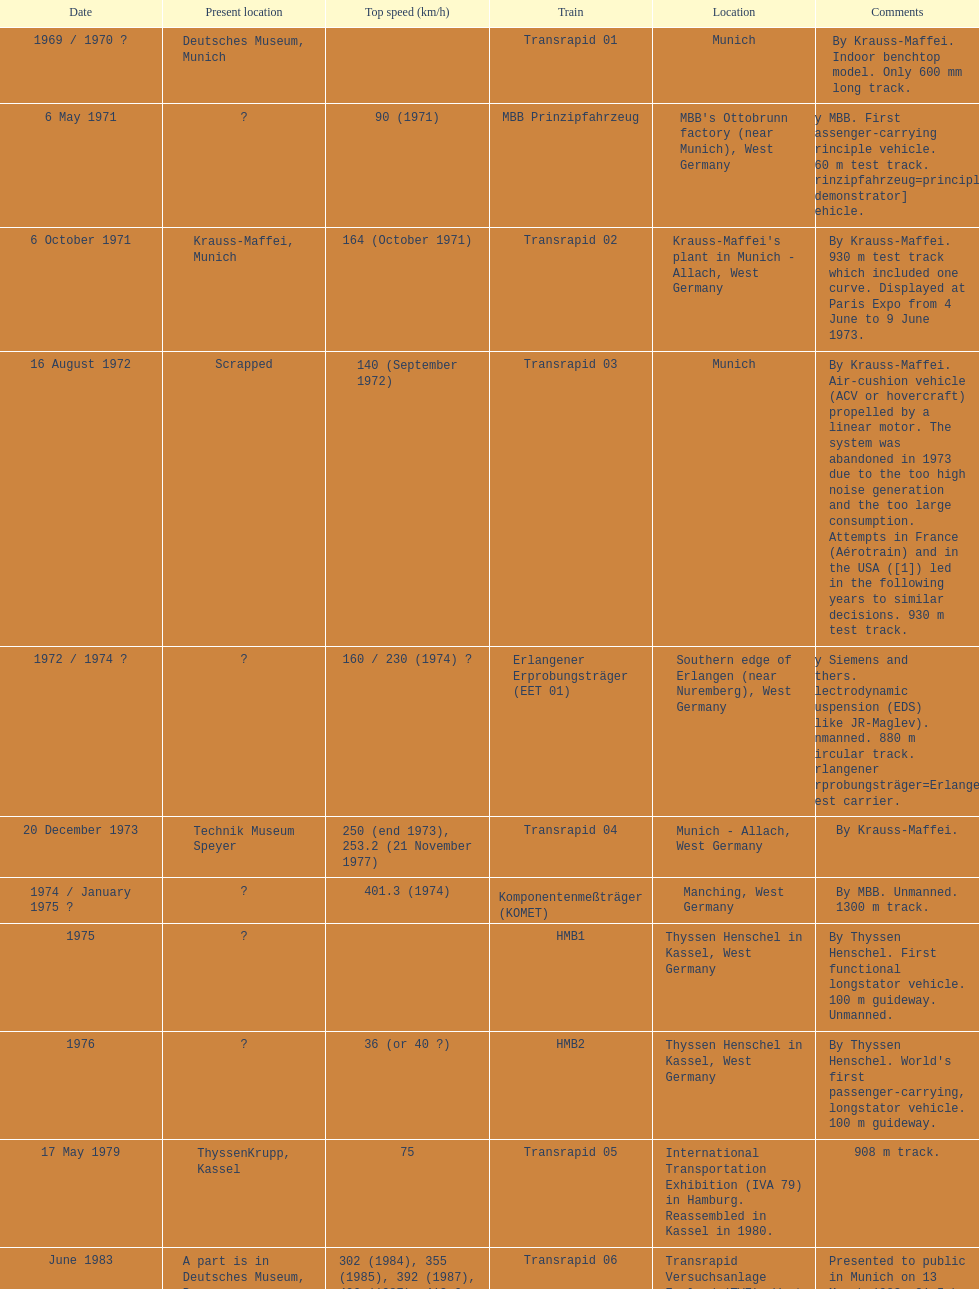What is the only train to reach a top speed of 500 or more? Transrapid SMT. 